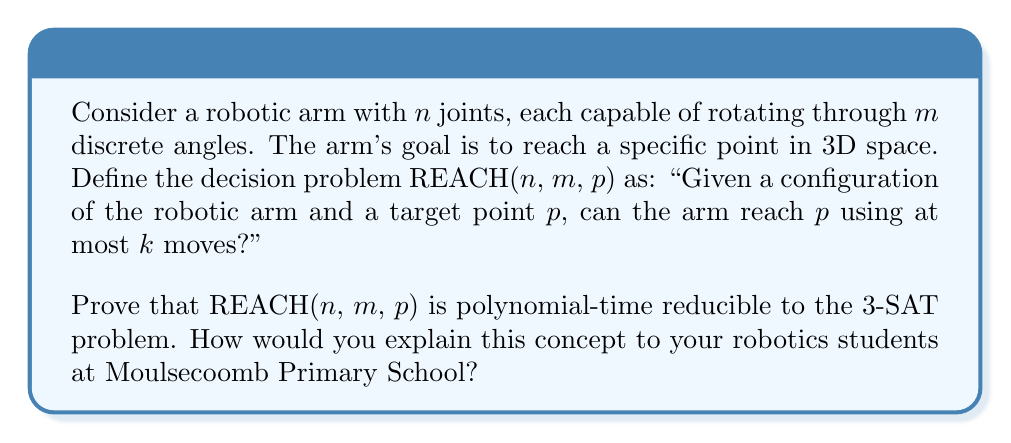Teach me how to tackle this problem. To prove that REACH(n, m, p) is polynomial-time reducible to 3-SAT, we need to show that we can transform any instance of REACH into an instance of 3-SAT in polynomial time. Here's a step-by-step explanation:

1. Represent the robotic arm configuration:
   For each joint $i$ and each possible angle $j$, create a boolean variable $x_{i,j}$. If $x_{i,j}$ is true, it means joint $i$ is at angle $j$.

2. Create clauses to ensure each joint is at exactly one angle:
   For each joint $i$:
   $$(\bigvee_{j=1}^m x_{i,j}) \wedge \bigwedge_{1\leq j<k\leq m} (\neg x_{i,j} \vee \neg x_{i,k})$$

3. Represent the target point:
   Create boolean variables for the x, y, and z coordinates of the target point, using binary encoding. For example, if the x-coordinate ranges from 0 to 15, use 4 boolean variables: $p_x^1, p_x^2, p_x^3, p_x^4$.

4. Create clauses to relate joint angles to the arm's end position:
   Use boolean logic to express the relationship between joint angles and the end position coordinates. This will involve multiple clauses combining joint angle variables and position variables.

5. Limit the number of moves:
   Introduce variables to represent the state of each joint at each move, up to k moves. Create clauses to ensure that only one joint changes per move and that the final state reaches the target point.

6. Combine all clauses:
   The final 3-SAT formula is the conjunction of all clauses created in steps 2-5.

This reduction can be performed in polynomial time relative to n, m, and the number of bits used to represent the target point coordinates. The resulting 3-SAT instance is satisfiable if and only if the robotic arm can reach the target point in at most k moves.

To explain this to primary school students, you could use a simplified analogy:
Imagine the robotic arm as a series of connected sticks, each able to point in different directions. The 3-SAT problem is like a giant puzzle where we need to figure out how to arrange the sticks to reach a specific point. We're turning the problem of moving the arm into a set of yes/no questions (like the boolean variables in 3-SAT) about how each stick should be positioned.
Answer: REACH(n, m, p) is polynomial-time reducible to 3-SAT. The reduction involves encoding the robotic arm's joint angles, target point coordinates, and movement constraints as boolean variables and clauses in a 3-SAT formula. This transformation can be done in polynomial time, and the resulting 3-SAT instance is satisfiable if and only if the original REACH problem has a solution. 